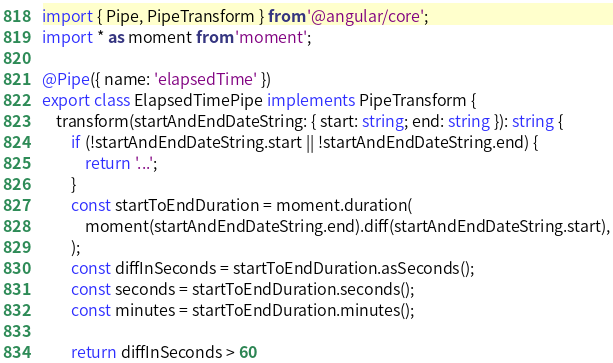Convert code to text. <code><loc_0><loc_0><loc_500><loc_500><_TypeScript_>import { Pipe, PipeTransform } from '@angular/core';
import * as moment from 'moment';

@Pipe({ name: 'elapsedTime' })
export class ElapsedTimePipe implements PipeTransform {
    transform(startAndEndDateString: { start: string; end: string }): string {
        if (!startAndEndDateString.start || !startAndEndDateString.end) {
            return '...';
        }
        const startToEndDuration = moment.duration(
            moment(startAndEndDateString.end).diff(startAndEndDateString.start),
        );
        const diffInSeconds = startToEndDuration.asSeconds();
        const seconds = startToEndDuration.seconds();
        const minutes = startToEndDuration.minutes();

        return diffInSeconds > 60</code> 